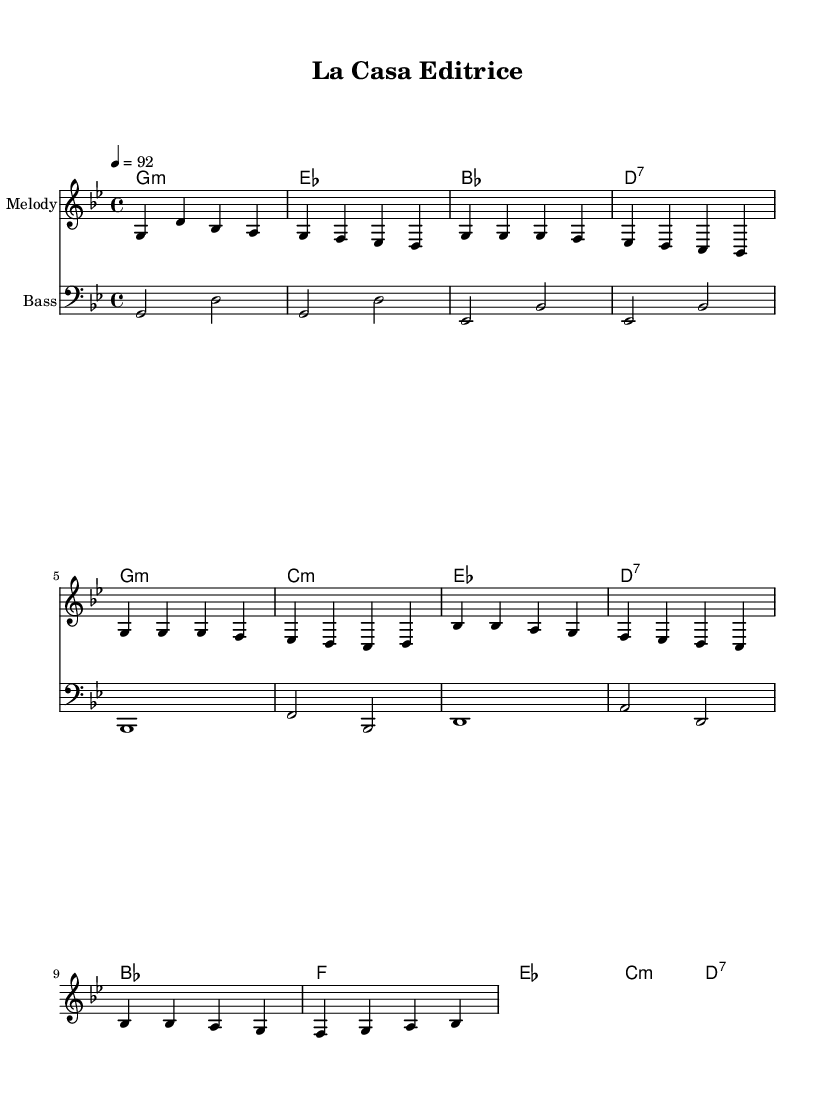What is the time signature of this music? The time signature is indicated at the beginning of the score and shows a 4 over 4 notation (4/4), which means there are four beats in each measure and the quarter note gets one beat.
Answer: 4/4 What is the key signature of this music? The key signature is found at the beginning of the score and indicates that the piece is in G minor, which has two flats (B flat and E flat).
Answer: G minor What is the tempo of this music? The tempo marking can be found in the score and is set to 92 beats per minute, indicating that the beats should be played at this speed.
Answer: 92 How many measures are in the verse section? The verse section contains four lines of music, and each line has four measures, for a total of 16 measures in the verse.
Answer: 16 What is the chord progression for the chorus? The chord progression for the chorus goes from B flat to F, then E flat to C minor, and ends on D7, as indicated in the chord mode section of the score.
Answer: B flat, F, E flat, C minor, D7 What type of musical piece is this? The structure, rhythm, and lyrical elements present in the score suggest that this is a hip-hop rap piece, which is often characterized by rhythmic speech and a strong backbeat.
Answer: Hip-hop 